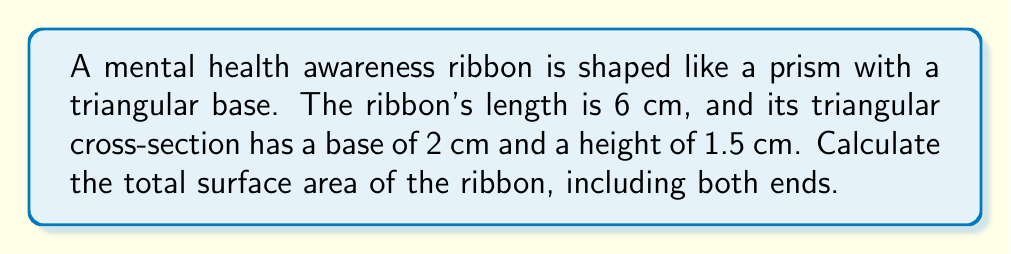Teach me how to tackle this problem. Let's approach this step-by-step:

1) First, we need to identify the shapes that make up the surface of the prism:
   - Two triangular ends
   - Three rectangular sides

2) Calculate the area of one triangular end:
   $A_{triangle} = \frac{1}{2} \times base \times height$
   $A_{triangle} = \frac{1}{2} \times 2 \times 1.5 = 1.5$ cm²

3) Calculate the areas of the rectangular sides:
   - Rectangle 1 (base of triangle): $2 \times 6 = 12$ cm²
   - Rectangle 2 and 3 (sides of triangle): 
     We need the slant height of the triangle: $\sqrt{1^2 + (1.5)^2} = \sqrt{3.25} \approx 1.803$ cm
     Area of each side rectangle: $1.803 \times 6 \approx 10.82$ cm²

4) Sum up all the areas:
   Total Surface Area = 2(area of triangle) + area of base rectangle + 2(area of side rectangle)
   $SA = 2(1.5) + 12 + 2(10.82) = 3 + 12 + 21.64 = 36.64$ cm²

[asy]
import geometry;

size(200);
pen thickp = linewidth(0.7);

pair A = (0,0), B = (2,0), C = (1,1.5);
pair A' = (6,0), B' = (8,0), C' = (7,1.5);

draw(A--B--C--cycle, thickp);
draw(A'--B'--C'--cycle, thickp);
draw(A--A', thickp);
draw(B--B', thickp);
draw(C--C', thickp);

label("6 cm", (3,-0.3), S);
label("2 cm", (1,0), S);
label("1.5 cm", (2.2,0.75), E);

[/asy]
Answer: $36.64$ cm² 